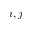Convert formula to latex. <formula><loc_0><loc_0><loc_500><loc_500>i , j</formula> 